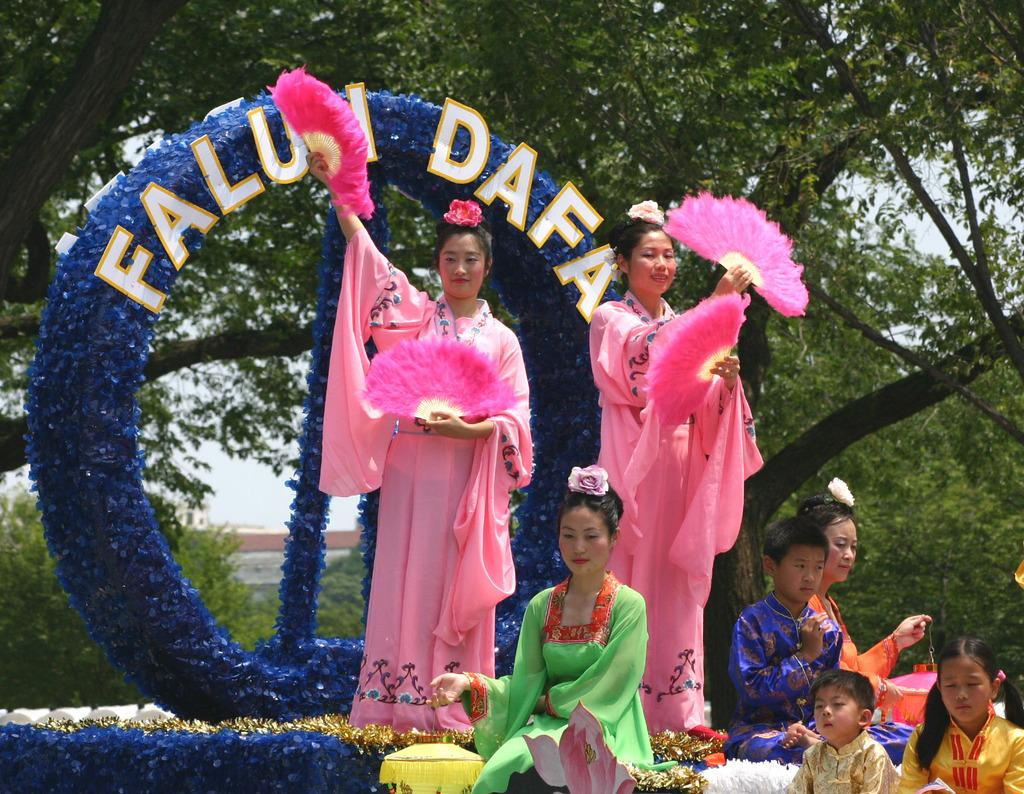Who is present in the image? There are people in the image, including children. What can be seen in the background of the image? There are trees in the background of the image. What are two people doing in the image? Two people are holding objects. What type of nose can be seen on the kettle in the image? There is no kettle present in the image, and therefore no nose can be observed on it. 